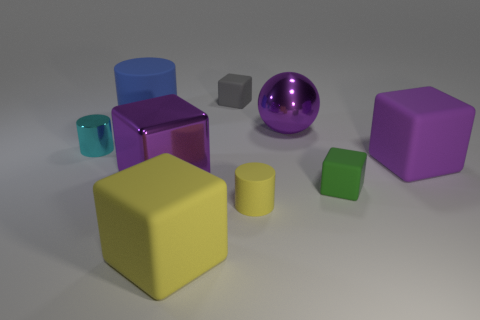Subtract 2 cubes. How many cubes are left? 3 Subtract all gray blocks. How many blocks are left? 4 Subtract all metal cubes. How many cubes are left? 4 Subtract all cyan cubes. Subtract all blue cylinders. How many cubes are left? 5 Add 1 green rubber objects. How many objects exist? 10 Subtract all blocks. How many objects are left? 4 Add 2 big red cubes. How many big red cubes exist? 2 Subtract 0 purple cylinders. How many objects are left? 9 Subtract all gray metal things. Subtract all green rubber cubes. How many objects are left? 8 Add 1 big cylinders. How many big cylinders are left? 2 